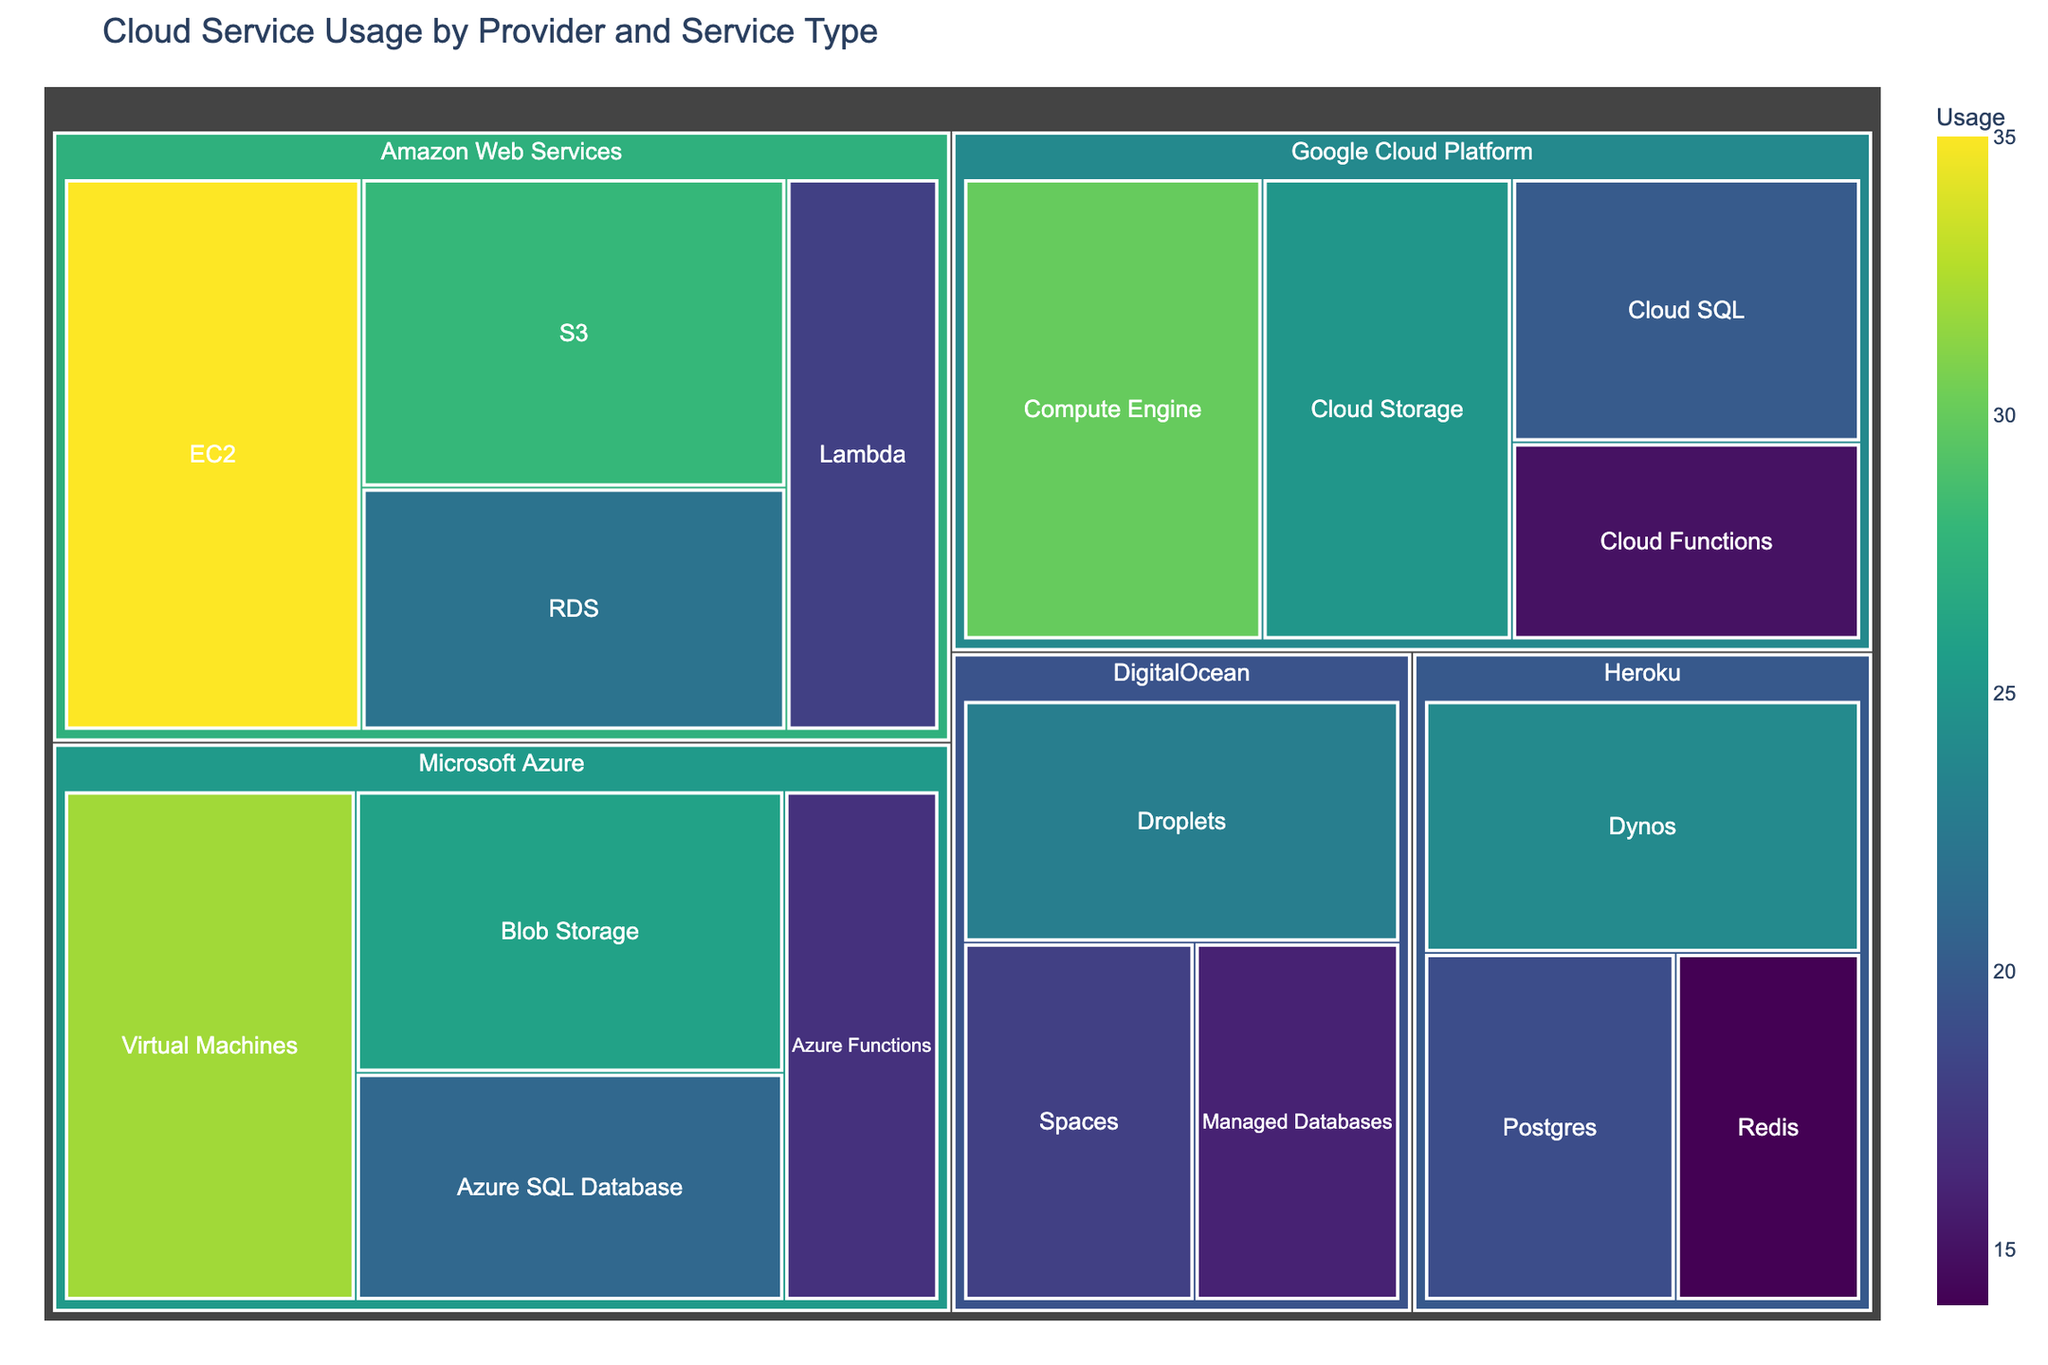What is the title of the Treemap? The title of the Treemap is displayed at the top of the figure and describes what the visualization is about.
Answer: Cloud Service Usage by Provider and Service Type How many providers are represented in the Treemap? To determine the number of providers, look at the top-most hierarchical level in the Treemap; each unique color block represents a provider.
Answer: 4 Which provider has the highest total usage? Sum the usage values for each service under each provider and compare the totals. The provider with the highest sum is the one with the highest total usage. Amazon Web Services has a total of 103 (35 + 28 + 22 + 18), Google Cloud Platform has 90 (30 + 25 + 20 + 15), Microsoft Azure has 96 (32 + 26 + 21 + 17), and Heroku has 57 (24 + 19 + 14). DigitalOcean has 57 (23 + 18 + 16). Therefore, Amazon Web Services has the highest total usage.
Answer: Amazon Web Services Which service has the lowest usage across all providers? Identify the smallest value among all the services listed in the Treemap.
Answer: Redis from Heroku (usage: 14) and Cloud Functions from Google Cloud Platform (usage: 15) share the lowest usage values Which provider offers the most diverse array of services? Count the number of different services each provider offers, and identify the provider with the highest count. Each of Amazon Web Services, Google Cloud Platform, Microsoft Azure, and DigitalOcean offer 4 services, while Heroku offers 3. Therefore, the first four providers tie.
Answer: Amazon Web Services, Google Cloud Platform, Microsoft Azure, and DigitalOcean Compare the usage of EC2 (Amazon Web Services) to Virtual Machines (Microsoft Azure). Which has higher usage? Look at the usage values of EC2 (35) and Virtual Machines (32). Compare the values to see which one is higher.
Answer: EC2 (Amazon Web Services) Which provider's services have the most uniformly distributed usage values? To determine uniform distribution, evaluate the range and variance in usage values for each provider. Microsoft Azure has usage values of (32, 26, 21, 17) with a range of 15. Compare the ranges and variances of each provider; the provider with the smallest range or variance is the most uniform. After comparison, Heroku with (24, 19, 14) shows the lowest range of 10, indicating the most uniform distribution.
Answer: Heroku 